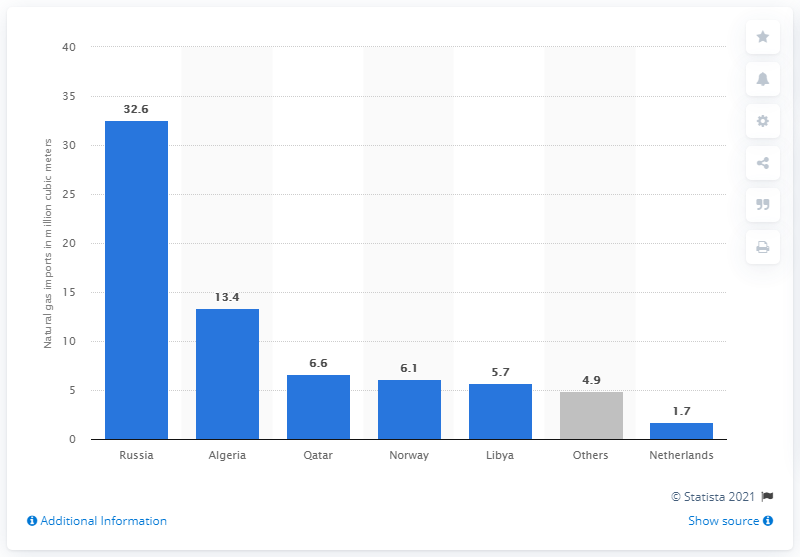Give some essential details in this illustration. In 2019, Italy imported 6.6 gigagrams (Gg) of natural gas from Qatar. In 2019, Russia was the primary provider of natural gas to Italy. 